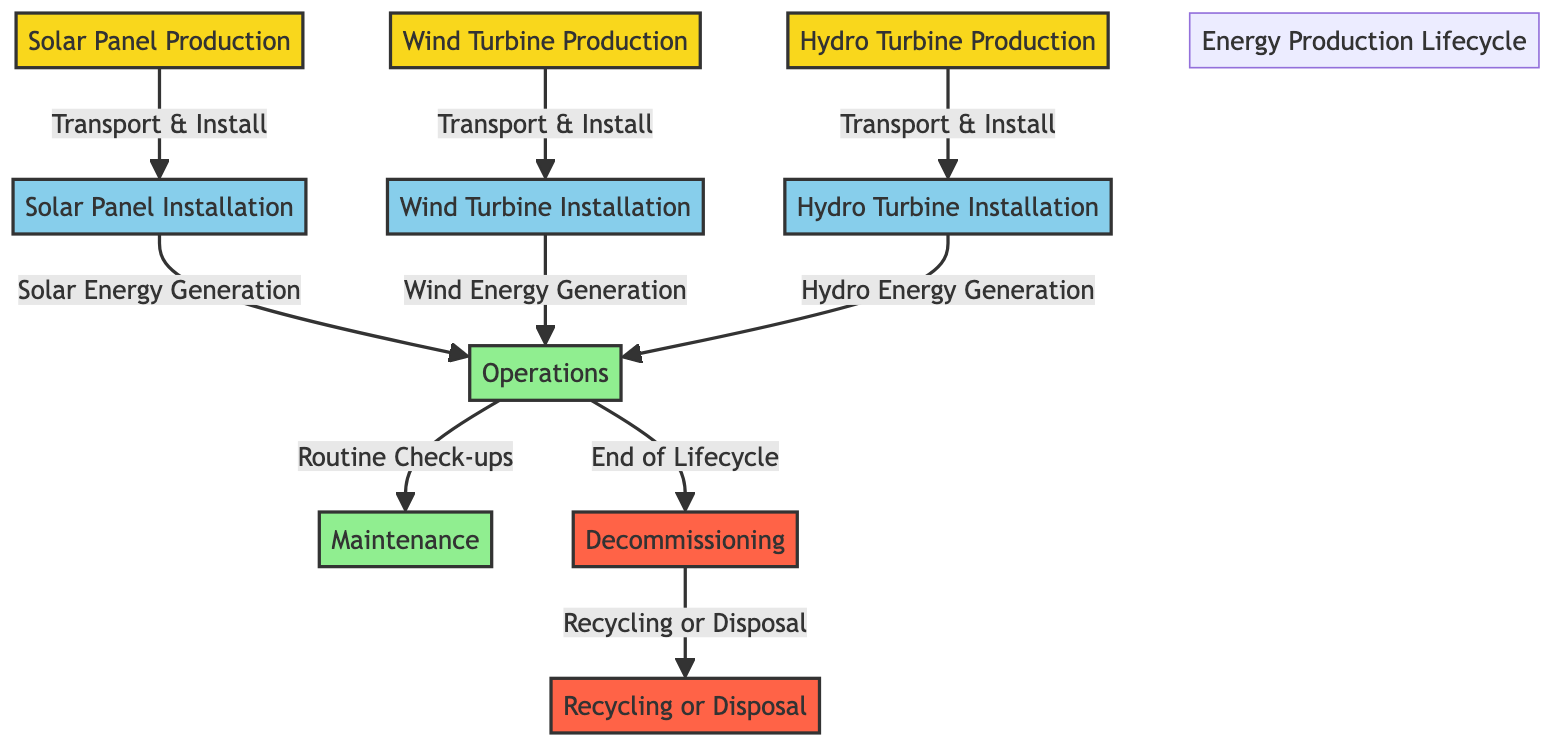What are the three types of renewable energy production shown? The diagram displays three types of renewable energy production: solar, wind, and hydro. They are prominently listed in their respective nodes at the beginning of the flowchart.
Answer: Solar, Wind, Hydro What is the last phase in the energy production lifecycle? The last phase depicted in the diagram is decommissioning, which directly connects to the recycling or disposal node. This is identified as the end of the lifecycle flow.
Answer: Decommissioning How many main production types are indicated in the diagram? The diagram indicates three main production types: solar panel, wind turbine, and hydro turbine. Each production type has its distinct node in the flowchart.
Answer: 3 What action follows 'Operations' in the diagram? Following 'Operations,' the action identified in the diagram is 'End of Lifecycle,' which transitions to the decommissioning node. This shows the sequence of activities.
Answer: Decommissioning What processes occur before maintenance? Before maintenance, the process that occurs is 'Routine Check-ups,' which takes place after 'Operations' and leads to maintaining the renewable energy systems.
Answer: Routine Check-ups Which renewable technology has a specified installation phase represented in the diagram? The installation phases are separately specified for solar, wind, and hydro technologies in the diagram—indicating clear steps for each type of energy technology.
Answer: Solar, Wind, Hydro What phase follows the 'Transport & Install' action for solar panels? After 'Transport & Install' for solar panels, the next phase is 'Solar Energy Generation,' which is the operational step that utilizes the installed panels.
Answer: Solar Energy Generation What are the two outcomes of decommissioning as shown in the diagram? The two outcomes of decommissioning are 'Recycling' or 'Disposal,' which indicate the final processing of equipment at the end of its lifecycle as shown in the recycling node.
Answer: Recycling, Disposal 